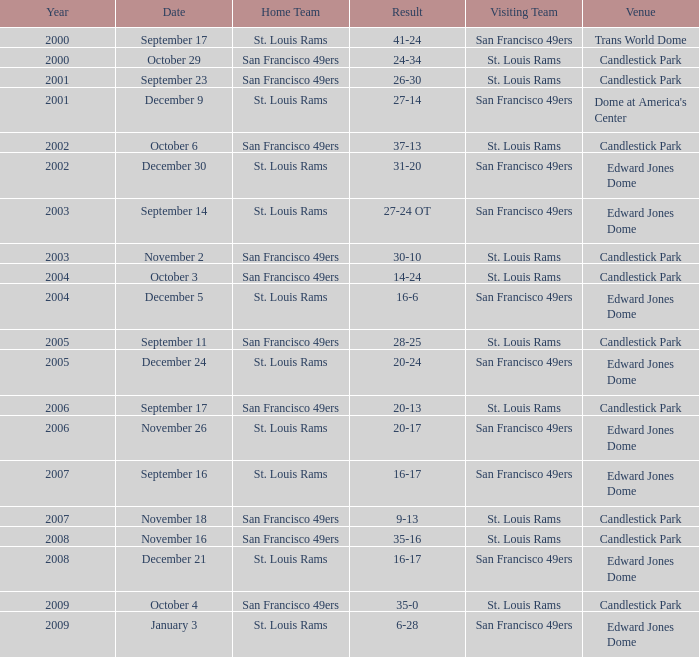Where was the 2009 st. louis rams home game held? Edward Jones Dome. 